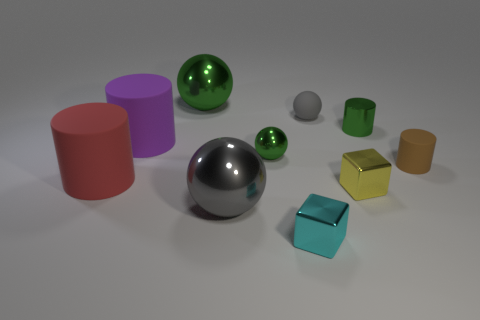How many matte things are large green things or red blocks?
Offer a very short reply. 0. What shape is the large red object?
Your response must be concise. Cylinder. Are there any other things that have the same material as the big green object?
Provide a short and direct response. Yes. Do the brown cylinder and the small cyan thing have the same material?
Provide a succinct answer. No. There is a large shiny thing in front of the small cylinder to the left of the tiny brown thing; is there a metallic thing that is behind it?
Offer a terse response. Yes. How many other objects are there of the same shape as the cyan object?
Offer a very short reply. 1. What shape is the green object that is both in front of the tiny gray rubber ball and on the left side of the green cylinder?
Make the answer very short. Sphere. The big metal thing behind the metal sphere that is in front of the metal cube that is behind the large gray ball is what color?
Offer a very short reply. Green. Are there more metallic cylinders that are to the right of the brown cylinder than red cylinders in front of the gray matte sphere?
Offer a terse response. No. What number of other objects are the same size as the cyan metallic object?
Your answer should be very brief. 5. 